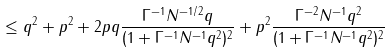Convert formula to latex. <formula><loc_0><loc_0><loc_500><loc_500>\leq \| q \| ^ { 2 } + \| p \| ^ { 2 } + 2 \| p \| \| q \| \frac { \Gamma ^ { - 1 } N ^ { - 1 / 2 } \| q \| } { ( 1 + \Gamma ^ { - 1 } N ^ { - 1 } \| q \| ^ { 2 } ) ^ { 2 } } + \| p \| ^ { 2 } \frac { \Gamma ^ { - 2 } N ^ { - 1 } \| q \| ^ { 2 } } { ( 1 + \Gamma ^ { - 1 } N ^ { - 1 } \| q \| ^ { 2 } ) ^ { 2 } }</formula> 